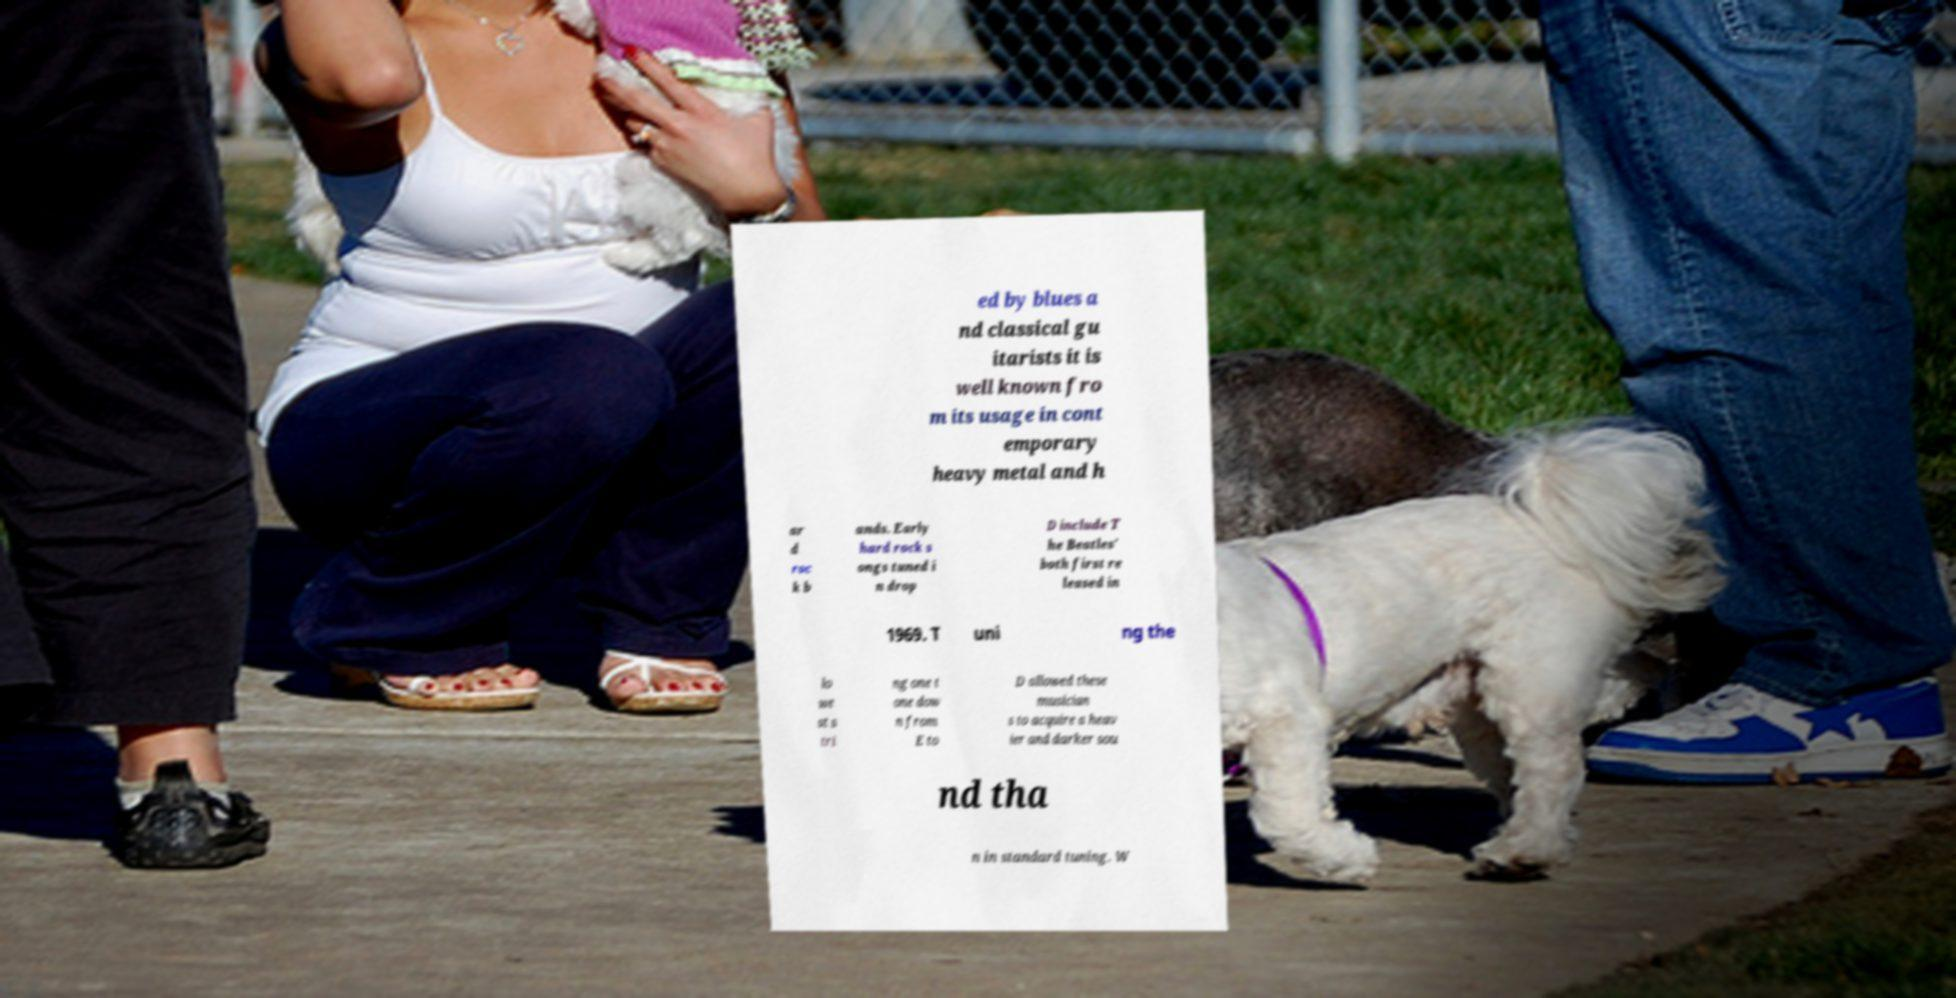Please identify and transcribe the text found in this image. ed by blues a nd classical gu itarists it is well known fro m its usage in cont emporary heavy metal and h ar d roc k b ands. Early hard rock s ongs tuned i n drop D include T he Beatles' both first re leased in 1969. T uni ng the lo we st s tri ng one t one dow n from E to D allowed these musician s to acquire a heav ier and darker sou nd tha n in standard tuning. W 